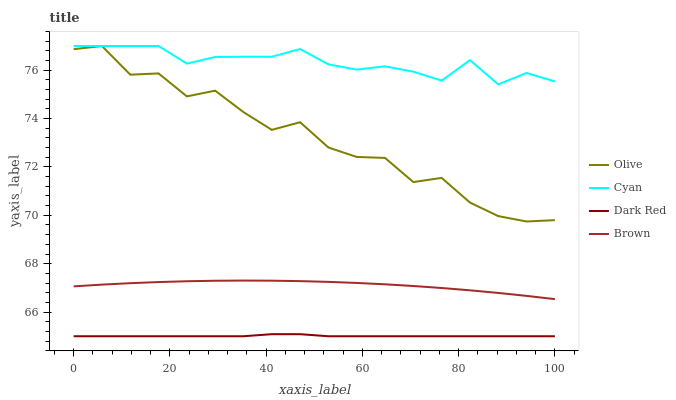Does Brown have the minimum area under the curve?
Answer yes or no. No. Does Brown have the maximum area under the curve?
Answer yes or no. No. Is Cyan the smoothest?
Answer yes or no. No. Is Cyan the roughest?
Answer yes or no. No. Does Brown have the lowest value?
Answer yes or no. No. Does Brown have the highest value?
Answer yes or no. No. Is Dark Red less than Cyan?
Answer yes or no. Yes. Is Olive greater than Brown?
Answer yes or no. Yes. Does Dark Red intersect Cyan?
Answer yes or no. No. 